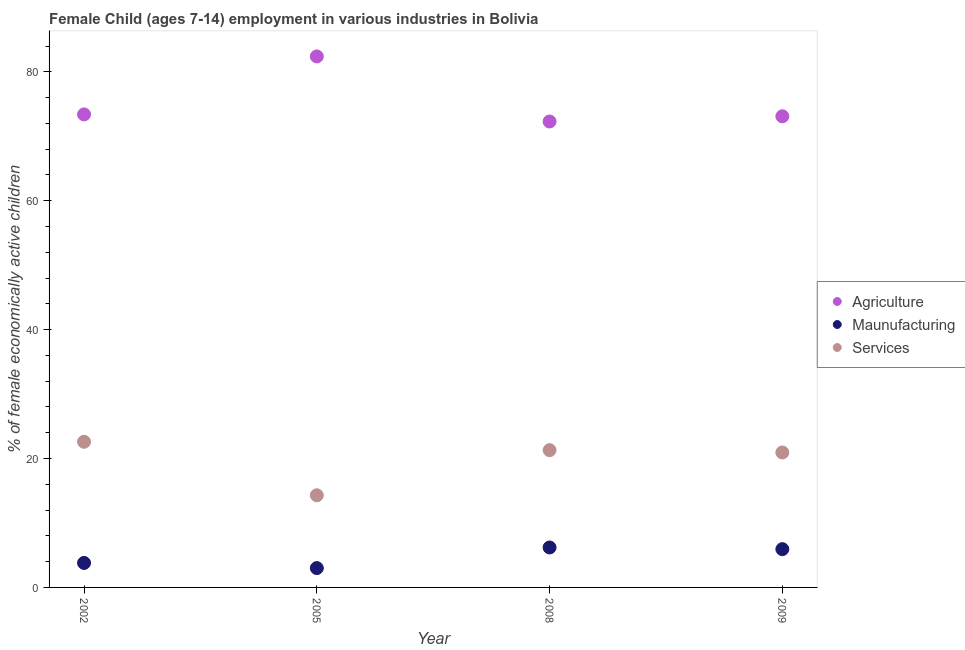How many different coloured dotlines are there?
Offer a very short reply. 3. Is the number of dotlines equal to the number of legend labels?
Offer a very short reply. Yes. What is the percentage of economically active children in agriculture in 2002?
Make the answer very short. 73.4. Across all years, what is the maximum percentage of economically active children in agriculture?
Your response must be concise. 82.4. Across all years, what is the minimum percentage of economically active children in agriculture?
Offer a very short reply. 72.3. What is the total percentage of economically active children in services in the graph?
Ensure brevity in your answer.  79.14. What is the difference between the percentage of economically active children in services in 2009 and the percentage of economically active children in agriculture in 2008?
Make the answer very short. -51.36. What is the average percentage of economically active children in manufacturing per year?
Your answer should be compact. 4.74. In the year 2008, what is the difference between the percentage of economically active children in manufacturing and percentage of economically active children in services?
Make the answer very short. -15.1. What is the ratio of the percentage of economically active children in agriculture in 2008 to that in 2009?
Your answer should be very brief. 0.99. Is the percentage of economically active children in services in 2005 less than that in 2008?
Your answer should be very brief. Yes. Is the difference between the percentage of economically active children in agriculture in 2005 and 2008 greater than the difference between the percentage of economically active children in manufacturing in 2005 and 2008?
Your answer should be compact. Yes. What is the difference between the highest and the second highest percentage of economically active children in services?
Offer a very short reply. 1.3. What is the difference between the highest and the lowest percentage of economically active children in services?
Offer a very short reply. 8.3. In how many years, is the percentage of economically active children in manufacturing greater than the average percentage of economically active children in manufacturing taken over all years?
Offer a very short reply. 2. Is the percentage of economically active children in agriculture strictly greater than the percentage of economically active children in manufacturing over the years?
Provide a succinct answer. Yes. Is the percentage of economically active children in manufacturing strictly less than the percentage of economically active children in agriculture over the years?
Offer a very short reply. Yes. How many years are there in the graph?
Make the answer very short. 4. What is the difference between two consecutive major ticks on the Y-axis?
Provide a short and direct response. 20. Are the values on the major ticks of Y-axis written in scientific E-notation?
Your answer should be compact. No. Does the graph contain any zero values?
Your response must be concise. No. Does the graph contain grids?
Keep it short and to the point. No. Where does the legend appear in the graph?
Your answer should be compact. Center right. How many legend labels are there?
Give a very brief answer. 3. How are the legend labels stacked?
Your answer should be compact. Vertical. What is the title of the graph?
Offer a terse response. Female Child (ages 7-14) employment in various industries in Bolivia. What is the label or title of the Y-axis?
Give a very brief answer. % of female economically active children. What is the % of female economically active children of Agriculture in 2002?
Your answer should be very brief. 73.4. What is the % of female economically active children of Maunufacturing in 2002?
Your response must be concise. 3.8. What is the % of female economically active children in Services in 2002?
Your answer should be compact. 22.6. What is the % of female economically active children in Agriculture in 2005?
Ensure brevity in your answer.  82.4. What is the % of female economically active children in Maunufacturing in 2005?
Offer a terse response. 3. What is the % of female economically active children in Agriculture in 2008?
Your answer should be compact. 72.3. What is the % of female economically active children in Maunufacturing in 2008?
Your answer should be very brief. 6.2. What is the % of female economically active children of Services in 2008?
Keep it short and to the point. 21.3. What is the % of female economically active children of Agriculture in 2009?
Ensure brevity in your answer.  73.11. What is the % of female economically active children in Maunufacturing in 2009?
Make the answer very short. 5.94. What is the % of female economically active children of Services in 2009?
Offer a very short reply. 20.94. Across all years, what is the maximum % of female economically active children of Agriculture?
Your answer should be very brief. 82.4. Across all years, what is the maximum % of female economically active children of Services?
Offer a terse response. 22.6. Across all years, what is the minimum % of female economically active children of Agriculture?
Your answer should be compact. 72.3. Across all years, what is the minimum % of female economically active children in Services?
Provide a succinct answer. 14.3. What is the total % of female economically active children of Agriculture in the graph?
Provide a succinct answer. 301.21. What is the total % of female economically active children of Maunufacturing in the graph?
Give a very brief answer. 18.94. What is the total % of female economically active children in Services in the graph?
Your answer should be very brief. 79.14. What is the difference between the % of female economically active children in Services in 2002 and that in 2005?
Provide a short and direct response. 8.3. What is the difference between the % of female economically active children in Agriculture in 2002 and that in 2009?
Ensure brevity in your answer.  0.29. What is the difference between the % of female economically active children of Maunufacturing in 2002 and that in 2009?
Give a very brief answer. -2.14. What is the difference between the % of female economically active children in Services in 2002 and that in 2009?
Give a very brief answer. 1.66. What is the difference between the % of female economically active children in Maunufacturing in 2005 and that in 2008?
Your answer should be compact. -3.2. What is the difference between the % of female economically active children of Services in 2005 and that in 2008?
Your response must be concise. -7. What is the difference between the % of female economically active children of Agriculture in 2005 and that in 2009?
Make the answer very short. 9.29. What is the difference between the % of female economically active children in Maunufacturing in 2005 and that in 2009?
Give a very brief answer. -2.94. What is the difference between the % of female economically active children of Services in 2005 and that in 2009?
Provide a succinct answer. -6.64. What is the difference between the % of female economically active children of Agriculture in 2008 and that in 2009?
Offer a very short reply. -0.81. What is the difference between the % of female economically active children of Maunufacturing in 2008 and that in 2009?
Your answer should be compact. 0.26. What is the difference between the % of female economically active children in Services in 2008 and that in 2009?
Your answer should be compact. 0.36. What is the difference between the % of female economically active children of Agriculture in 2002 and the % of female economically active children of Maunufacturing in 2005?
Offer a terse response. 70.4. What is the difference between the % of female economically active children in Agriculture in 2002 and the % of female economically active children in Services in 2005?
Provide a short and direct response. 59.1. What is the difference between the % of female economically active children in Agriculture in 2002 and the % of female economically active children in Maunufacturing in 2008?
Make the answer very short. 67.2. What is the difference between the % of female economically active children in Agriculture in 2002 and the % of female economically active children in Services in 2008?
Your answer should be very brief. 52.1. What is the difference between the % of female economically active children in Maunufacturing in 2002 and the % of female economically active children in Services in 2008?
Your answer should be very brief. -17.5. What is the difference between the % of female economically active children in Agriculture in 2002 and the % of female economically active children in Maunufacturing in 2009?
Provide a short and direct response. 67.46. What is the difference between the % of female economically active children in Agriculture in 2002 and the % of female economically active children in Services in 2009?
Give a very brief answer. 52.46. What is the difference between the % of female economically active children of Maunufacturing in 2002 and the % of female economically active children of Services in 2009?
Provide a succinct answer. -17.14. What is the difference between the % of female economically active children in Agriculture in 2005 and the % of female economically active children in Maunufacturing in 2008?
Offer a very short reply. 76.2. What is the difference between the % of female economically active children of Agriculture in 2005 and the % of female economically active children of Services in 2008?
Give a very brief answer. 61.1. What is the difference between the % of female economically active children in Maunufacturing in 2005 and the % of female economically active children in Services in 2008?
Make the answer very short. -18.3. What is the difference between the % of female economically active children in Agriculture in 2005 and the % of female economically active children in Maunufacturing in 2009?
Offer a terse response. 76.46. What is the difference between the % of female economically active children in Agriculture in 2005 and the % of female economically active children in Services in 2009?
Offer a terse response. 61.46. What is the difference between the % of female economically active children of Maunufacturing in 2005 and the % of female economically active children of Services in 2009?
Your answer should be very brief. -17.94. What is the difference between the % of female economically active children of Agriculture in 2008 and the % of female economically active children of Maunufacturing in 2009?
Provide a short and direct response. 66.36. What is the difference between the % of female economically active children of Agriculture in 2008 and the % of female economically active children of Services in 2009?
Your response must be concise. 51.36. What is the difference between the % of female economically active children of Maunufacturing in 2008 and the % of female economically active children of Services in 2009?
Your answer should be very brief. -14.74. What is the average % of female economically active children in Agriculture per year?
Provide a succinct answer. 75.3. What is the average % of female economically active children in Maunufacturing per year?
Provide a succinct answer. 4.74. What is the average % of female economically active children of Services per year?
Offer a very short reply. 19.79. In the year 2002, what is the difference between the % of female economically active children in Agriculture and % of female economically active children in Maunufacturing?
Provide a succinct answer. 69.6. In the year 2002, what is the difference between the % of female economically active children in Agriculture and % of female economically active children in Services?
Ensure brevity in your answer.  50.8. In the year 2002, what is the difference between the % of female economically active children of Maunufacturing and % of female economically active children of Services?
Provide a succinct answer. -18.8. In the year 2005, what is the difference between the % of female economically active children of Agriculture and % of female economically active children of Maunufacturing?
Your answer should be very brief. 79.4. In the year 2005, what is the difference between the % of female economically active children of Agriculture and % of female economically active children of Services?
Keep it short and to the point. 68.1. In the year 2005, what is the difference between the % of female economically active children in Maunufacturing and % of female economically active children in Services?
Offer a very short reply. -11.3. In the year 2008, what is the difference between the % of female economically active children in Agriculture and % of female economically active children in Maunufacturing?
Provide a succinct answer. 66.1. In the year 2008, what is the difference between the % of female economically active children in Agriculture and % of female economically active children in Services?
Offer a terse response. 51. In the year 2008, what is the difference between the % of female economically active children of Maunufacturing and % of female economically active children of Services?
Provide a short and direct response. -15.1. In the year 2009, what is the difference between the % of female economically active children in Agriculture and % of female economically active children in Maunufacturing?
Make the answer very short. 67.17. In the year 2009, what is the difference between the % of female economically active children in Agriculture and % of female economically active children in Services?
Offer a very short reply. 52.17. In the year 2009, what is the difference between the % of female economically active children in Maunufacturing and % of female economically active children in Services?
Give a very brief answer. -15. What is the ratio of the % of female economically active children of Agriculture in 2002 to that in 2005?
Offer a terse response. 0.89. What is the ratio of the % of female economically active children of Maunufacturing in 2002 to that in 2005?
Your answer should be very brief. 1.27. What is the ratio of the % of female economically active children of Services in 2002 to that in 2005?
Give a very brief answer. 1.58. What is the ratio of the % of female economically active children in Agriculture in 2002 to that in 2008?
Provide a succinct answer. 1.02. What is the ratio of the % of female economically active children in Maunufacturing in 2002 to that in 2008?
Provide a short and direct response. 0.61. What is the ratio of the % of female economically active children of Services in 2002 to that in 2008?
Offer a terse response. 1.06. What is the ratio of the % of female economically active children of Maunufacturing in 2002 to that in 2009?
Provide a short and direct response. 0.64. What is the ratio of the % of female economically active children in Services in 2002 to that in 2009?
Give a very brief answer. 1.08. What is the ratio of the % of female economically active children in Agriculture in 2005 to that in 2008?
Your answer should be compact. 1.14. What is the ratio of the % of female economically active children of Maunufacturing in 2005 to that in 2008?
Offer a very short reply. 0.48. What is the ratio of the % of female economically active children in Services in 2005 to that in 2008?
Offer a very short reply. 0.67. What is the ratio of the % of female economically active children of Agriculture in 2005 to that in 2009?
Offer a very short reply. 1.13. What is the ratio of the % of female economically active children in Maunufacturing in 2005 to that in 2009?
Offer a terse response. 0.51. What is the ratio of the % of female economically active children of Services in 2005 to that in 2009?
Offer a terse response. 0.68. What is the ratio of the % of female economically active children of Agriculture in 2008 to that in 2009?
Your answer should be compact. 0.99. What is the ratio of the % of female economically active children in Maunufacturing in 2008 to that in 2009?
Your response must be concise. 1.04. What is the ratio of the % of female economically active children in Services in 2008 to that in 2009?
Provide a succinct answer. 1.02. What is the difference between the highest and the second highest % of female economically active children of Agriculture?
Make the answer very short. 9. What is the difference between the highest and the second highest % of female economically active children in Maunufacturing?
Keep it short and to the point. 0.26. What is the difference between the highest and the second highest % of female economically active children of Services?
Offer a very short reply. 1.3. What is the difference between the highest and the lowest % of female economically active children of Agriculture?
Provide a short and direct response. 10.1. What is the difference between the highest and the lowest % of female economically active children of Maunufacturing?
Provide a short and direct response. 3.2. 